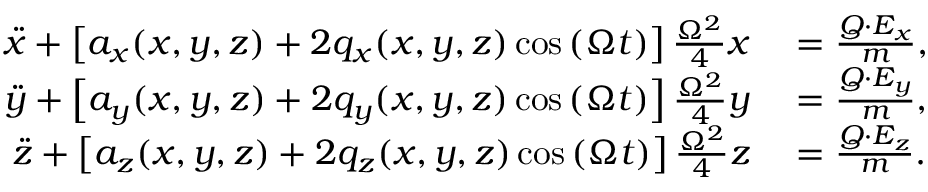Convert formula to latex. <formula><loc_0><loc_0><loc_500><loc_500>\begin{array} { r l } { \ddot { x } + \left [ a _ { x } ( x , y , z ) + 2 q _ { x } ( x , y , z ) \cos \left ( \Omega t \right ) \right ] \frac { \Omega ^ { 2 } } { 4 } x } & = \frac { Q \cdot E _ { x } } { m } , } \\ { \ddot { y } + \left [ a _ { y } ( x , y , z ) + 2 q _ { y } ( x , y , z ) \cos \left ( \Omega t \right ) \right ] \frac { \Omega ^ { 2 } } { 4 } y } & = \frac { Q \cdot E _ { y } } { m } , } \\ { \ddot { z } + \left [ a _ { z } ( x , y , z ) + 2 q _ { z } ( x , y , z ) \cos \left ( \Omega t \right ) \right ] \frac { \Omega ^ { 2 } } { 4 } z } & = \frac { Q \cdot E _ { z } } { m } . } \end{array}</formula> 